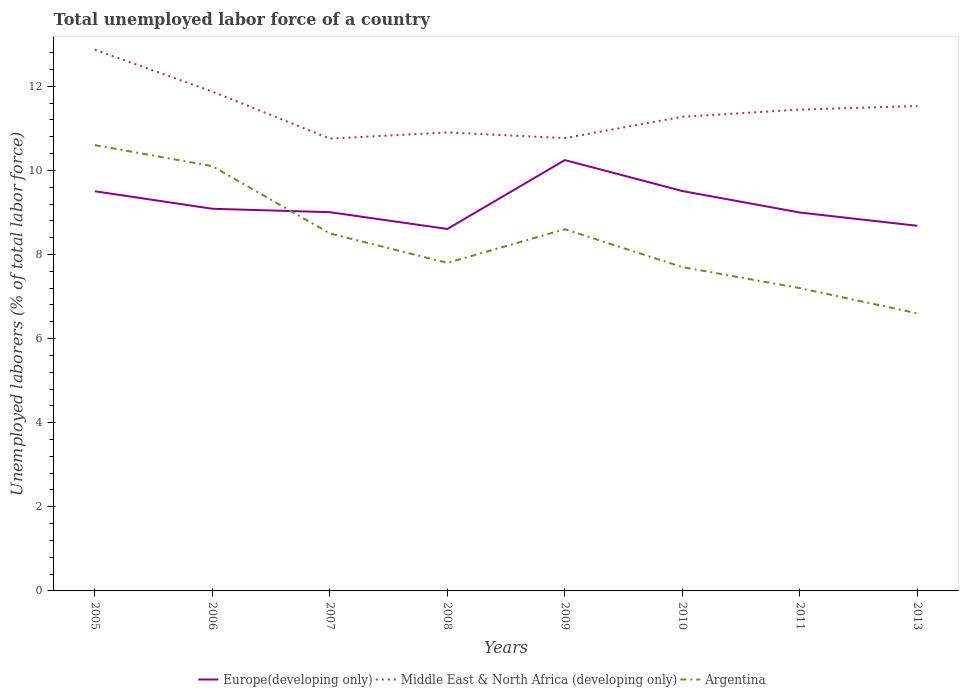How many different coloured lines are there?
Provide a short and direct response. 3. Is the number of lines equal to the number of legend labels?
Your answer should be very brief. Yes. Across all years, what is the maximum total unemployed labor force in Middle East & North Africa (developing only)?
Make the answer very short. 10.75. What is the total total unemployed labor force in Argentina in the graph?
Make the answer very short. 1.1. What is the difference between the highest and the second highest total unemployed labor force in Middle East & North Africa (developing only)?
Keep it short and to the point. 2.11. How many years are there in the graph?
Ensure brevity in your answer.  8. What is the difference between two consecutive major ticks on the Y-axis?
Make the answer very short. 2. Does the graph contain any zero values?
Offer a terse response. No. Does the graph contain grids?
Give a very brief answer. No. How many legend labels are there?
Give a very brief answer. 3. What is the title of the graph?
Your answer should be very brief. Total unemployed labor force of a country. What is the label or title of the Y-axis?
Offer a very short reply. Unemployed laborers (% of total labor force). What is the Unemployed laborers (% of total labor force) in Europe(developing only) in 2005?
Your answer should be very brief. 9.5. What is the Unemployed laborers (% of total labor force) of Middle East & North Africa (developing only) in 2005?
Keep it short and to the point. 12.87. What is the Unemployed laborers (% of total labor force) in Argentina in 2005?
Your answer should be compact. 10.6. What is the Unemployed laborers (% of total labor force) of Europe(developing only) in 2006?
Make the answer very short. 9.09. What is the Unemployed laborers (% of total labor force) of Middle East & North Africa (developing only) in 2006?
Ensure brevity in your answer.  11.87. What is the Unemployed laborers (% of total labor force) of Argentina in 2006?
Keep it short and to the point. 10.1. What is the Unemployed laborers (% of total labor force) in Europe(developing only) in 2007?
Provide a succinct answer. 9.01. What is the Unemployed laborers (% of total labor force) of Middle East & North Africa (developing only) in 2007?
Make the answer very short. 10.75. What is the Unemployed laborers (% of total labor force) in Argentina in 2007?
Offer a terse response. 8.5. What is the Unemployed laborers (% of total labor force) of Europe(developing only) in 2008?
Provide a succinct answer. 8.61. What is the Unemployed laborers (% of total labor force) of Middle East & North Africa (developing only) in 2008?
Your response must be concise. 10.9. What is the Unemployed laborers (% of total labor force) of Argentina in 2008?
Ensure brevity in your answer.  7.8. What is the Unemployed laborers (% of total labor force) in Europe(developing only) in 2009?
Your answer should be very brief. 10.24. What is the Unemployed laborers (% of total labor force) in Middle East & North Africa (developing only) in 2009?
Provide a succinct answer. 10.77. What is the Unemployed laborers (% of total labor force) in Argentina in 2009?
Ensure brevity in your answer.  8.6. What is the Unemployed laborers (% of total labor force) of Europe(developing only) in 2010?
Offer a terse response. 9.51. What is the Unemployed laborers (% of total labor force) of Middle East & North Africa (developing only) in 2010?
Offer a terse response. 11.28. What is the Unemployed laborers (% of total labor force) of Argentina in 2010?
Offer a terse response. 7.7. What is the Unemployed laborers (% of total labor force) of Europe(developing only) in 2011?
Ensure brevity in your answer.  9. What is the Unemployed laborers (% of total labor force) of Middle East & North Africa (developing only) in 2011?
Give a very brief answer. 11.44. What is the Unemployed laborers (% of total labor force) of Argentina in 2011?
Provide a short and direct response. 7.2. What is the Unemployed laborers (% of total labor force) in Europe(developing only) in 2013?
Make the answer very short. 8.68. What is the Unemployed laborers (% of total labor force) of Middle East & North Africa (developing only) in 2013?
Make the answer very short. 11.53. What is the Unemployed laborers (% of total labor force) in Argentina in 2013?
Provide a short and direct response. 6.6. Across all years, what is the maximum Unemployed laborers (% of total labor force) of Europe(developing only)?
Keep it short and to the point. 10.24. Across all years, what is the maximum Unemployed laborers (% of total labor force) of Middle East & North Africa (developing only)?
Your response must be concise. 12.87. Across all years, what is the maximum Unemployed laborers (% of total labor force) in Argentina?
Ensure brevity in your answer.  10.6. Across all years, what is the minimum Unemployed laborers (% of total labor force) of Europe(developing only)?
Make the answer very short. 8.61. Across all years, what is the minimum Unemployed laborers (% of total labor force) in Middle East & North Africa (developing only)?
Ensure brevity in your answer.  10.75. Across all years, what is the minimum Unemployed laborers (% of total labor force) in Argentina?
Make the answer very short. 6.6. What is the total Unemployed laborers (% of total labor force) in Europe(developing only) in the graph?
Make the answer very short. 73.63. What is the total Unemployed laborers (% of total labor force) of Middle East & North Africa (developing only) in the graph?
Provide a short and direct response. 91.41. What is the total Unemployed laborers (% of total labor force) of Argentina in the graph?
Ensure brevity in your answer.  67.1. What is the difference between the Unemployed laborers (% of total labor force) of Europe(developing only) in 2005 and that in 2006?
Offer a terse response. 0.42. What is the difference between the Unemployed laborers (% of total labor force) in Argentina in 2005 and that in 2006?
Make the answer very short. 0.5. What is the difference between the Unemployed laborers (% of total labor force) in Europe(developing only) in 2005 and that in 2007?
Provide a short and direct response. 0.5. What is the difference between the Unemployed laborers (% of total labor force) in Middle East & North Africa (developing only) in 2005 and that in 2007?
Ensure brevity in your answer.  2.11. What is the difference between the Unemployed laborers (% of total labor force) of Europe(developing only) in 2005 and that in 2008?
Your response must be concise. 0.9. What is the difference between the Unemployed laborers (% of total labor force) in Middle East & North Africa (developing only) in 2005 and that in 2008?
Make the answer very short. 1.97. What is the difference between the Unemployed laborers (% of total labor force) of Europe(developing only) in 2005 and that in 2009?
Your answer should be compact. -0.74. What is the difference between the Unemployed laborers (% of total labor force) of Middle East & North Africa (developing only) in 2005 and that in 2009?
Your answer should be compact. 2.1. What is the difference between the Unemployed laborers (% of total labor force) of Argentina in 2005 and that in 2009?
Ensure brevity in your answer.  2. What is the difference between the Unemployed laborers (% of total labor force) of Europe(developing only) in 2005 and that in 2010?
Offer a terse response. -0.01. What is the difference between the Unemployed laborers (% of total labor force) in Middle East & North Africa (developing only) in 2005 and that in 2010?
Offer a terse response. 1.59. What is the difference between the Unemployed laborers (% of total labor force) in Europe(developing only) in 2005 and that in 2011?
Your response must be concise. 0.51. What is the difference between the Unemployed laborers (% of total labor force) in Middle East & North Africa (developing only) in 2005 and that in 2011?
Your response must be concise. 1.42. What is the difference between the Unemployed laborers (% of total labor force) of Europe(developing only) in 2005 and that in 2013?
Offer a terse response. 0.82. What is the difference between the Unemployed laborers (% of total labor force) of Middle East & North Africa (developing only) in 2005 and that in 2013?
Keep it short and to the point. 1.34. What is the difference between the Unemployed laborers (% of total labor force) of Europe(developing only) in 2006 and that in 2007?
Provide a short and direct response. 0.08. What is the difference between the Unemployed laborers (% of total labor force) in Middle East & North Africa (developing only) in 2006 and that in 2007?
Provide a short and direct response. 1.12. What is the difference between the Unemployed laborers (% of total labor force) in Argentina in 2006 and that in 2007?
Offer a very short reply. 1.6. What is the difference between the Unemployed laborers (% of total labor force) in Europe(developing only) in 2006 and that in 2008?
Ensure brevity in your answer.  0.48. What is the difference between the Unemployed laborers (% of total labor force) in Middle East & North Africa (developing only) in 2006 and that in 2008?
Ensure brevity in your answer.  0.97. What is the difference between the Unemployed laborers (% of total labor force) of Argentina in 2006 and that in 2008?
Your response must be concise. 2.3. What is the difference between the Unemployed laborers (% of total labor force) in Europe(developing only) in 2006 and that in 2009?
Your answer should be compact. -1.16. What is the difference between the Unemployed laborers (% of total labor force) of Middle East & North Africa (developing only) in 2006 and that in 2009?
Provide a short and direct response. 1.11. What is the difference between the Unemployed laborers (% of total labor force) of Argentina in 2006 and that in 2009?
Your answer should be compact. 1.5. What is the difference between the Unemployed laborers (% of total labor force) of Europe(developing only) in 2006 and that in 2010?
Provide a succinct answer. -0.42. What is the difference between the Unemployed laborers (% of total labor force) of Middle East & North Africa (developing only) in 2006 and that in 2010?
Your answer should be compact. 0.6. What is the difference between the Unemployed laborers (% of total labor force) in Europe(developing only) in 2006 and that in 2011?
Your answer should be very brief. 0.09. What is the difference between the Unemployed laborers (% of total labor force) of Middle East & North Africa (developing only) in 2006 and that in 2011?
Provide a short and direct response. 0.43. What is the difference between the Unemployed laborers (% of total labor force) of Argentina in 2006 and that in 2011?
Offer a very short reply. 2.9. What is the difference between the Unemployed laborers (% of total labor force) in Europe(developing only) in 2006 and that in 2013?
Give a very brief answer. 0.4. What is the difference between the Unemployed laborers (% of total labor force) of Middle East & North Africa (developing only) in 2006 and that in 2013?
Offer a very short reply. 0.34. What is the difference between the Unemployed laborers (% of total labor force) in Europe(developing only) in 2007 and that in 2008?
Give a very brief answer. 0.4. What is the difference between the Unemployed laborers (% of total labor force) in Middle East & North Africa (developing only) in 2007 and that in 2008?
Your response must be concise. -0.15. What is the difference between the Unemployed laborers (% of total labor force) in Argentina in 2007 and that in 2008?
Your response must be concise. 0.7. What is the difference between the Unemployed laborers (% of total labor force) of Europe(developing only) in 2007 and that in 2009?
Ensure brevity in your answer.  -1.24. What is the difference between the Unemployed laborers (% of total labor force) of Middle East & North Africa (developing only) in 2007 and that in 2009?
Give a very brief answer. -0.01. What is the difference between the Unemployed laborers (% of total labor force) in Argentina in 2007 and that in 2009?
Give a very brief answer. -0.1. What is the difference between the Unemployed laborers (% of total labor force) in Europe(developing only) in 2007 and that in 2010?
Ensure brevity in your answer.  -0.5. What is the difference between the Unemployed laborers (% of total labor force) of Middle East & North Africa (developing only) in 2007 and that in 2010?
Provide a succinct answer. -0.52. What is the difference between the Unemployed laborers (% of total labor force) of Argentina in 2007 and that in 2010?
Your answer should be compact. 0.8. What is the difference between the Unemployed laborers (% of total labor force) of Europe(developing only) in 2007 and that in 2011?
Ensure brevity in your answer.  0.01. What is the difference between the Unemployed laborers (% of total labor force) of Middle East & North Africa (developing only) in 2007 and that in 2011?
Offer a terse response. -0.69. What is the difference between the Unemployed laborers (% of total labor force) of Europe(developing only) in 2007 and that in 2013?
Make the answer very short. 0.32. What is the difference between the Unemployed laborers (% of total labor force) in Middle East & North Africa (developing only) in 2007 and that in 2013?
Offer a terse response. -0.77. What is the difference between the Unemployed laborers (% of total labor force) of Argentina in 2007 and that in 2013?
Your answer should be compact. 1.9. What is the difference between the Unemployed laborers (% of total labor force) of Europe(developing only) in 2008 and that in 2009?
Offer a very short reply. -1.64. What is the difference between the Unemployed laborers (% of total labor force) of Middle East & North Africa (developing only) in 2008 and that in 2009?
Offer a very short reply. 0.14. What is the difference between the Unemployed laborers (% of total labor force) in Europe(developing only) in 2008 and that in 2010?
Give a very brief answer. -0.9. What is the difference between the Unemployed laborers (% of total labor force) in Middle East & North Africa (developing only) in 2008 and that in 2010?
Offer a terse response. -0.37. What is the difference between the Unemployed laborers (% of total labor force) in Argentina in 2008 and that in 2010?
Offer a terse response. 0.1. What is the difference between the Unemployed laborers (% of total labor force) in Europe(developing only) in 2008 and that in 2011?
Your response must be concise. -0.39. What is the difference between the Unemployed laborers (% of total labor force) in Middle East & North Africa (developing only) in 2008 and that in 2011?
Provide a short and direct response. -0.54. What is the difference between the Unemployed laborers (% of total labor force) in Europe(developing only) in 2008 and that in 2013?
Your answer should be very brief. -0.08. What is the difference between the Unemployed laborers (% of total labor force) of Middle East & North Africa (developing only) in 2008 and that in 2013?
Provide a succinct answer. -0.63. What is the difference between the Unemployed laborers (% of total labor force) of Europe(developing only) in 2009 and that in 2010?
Your answer should be compact. 0.74. What is the difference between the Unemployed laborers (% of total labor force) in Middle East & North Africa (developing only) in 2009 and that in 2010?
Give a very brief answer. -0.51. What is the difference between the Unemployed laborers (% of total labor force) of Europe(developing only) in 2009 and that in 2011?
Ensure brevity in your answer.  1.25. What is the difference between the Unemployed laborers (% of total labor force) in Middle East & North Africa (developing only) in 2009 and that in 2011?
Offer a very short reply. -0.68. What is the difference between the Unemployed laborers (% of total labor force) of Europe(developing only) in 2009 and that in 2013?
Ensure brevity in your answer.  1.56. What is the difference between the Unemployed laborers (% of total labor force) of Middle East & North Africa (developing only) in 2009 and that in 2013?
Your answer should be very brief. -0.76. What is the difference between the Unemployed laborers (% of total labor force) of Europe(developing only) in 2010 and that in 2011?
Your answer should be compact. 0.51. What is the difference between the Unemployed laborers (% of total labor force) in Middle East & North Africa (developing only) in 2010 and that in 2011?
Give a very brief answer. -0.17. What is the difference between the Unemployed laborers (% of total labor force) of Argentina in 2010 and that in 2011?
Your answer should be very brief. 0.5. What is the difference between the Unemployed laborers (% of total labor force) in Europe(developing only) in 2010 and that in 2013?
Offer a terse response. 0.83. What is the difference between the Unemployed laborers (% of total labor force) in Middle East & North Africa (developing only) in 2010 and that in 2013?
Ensure brevity in your answer.  -0.25. What is the difference between the Unemployed laborers (% of total labor force) of Argentina in 2010 and that in 2013?
Provide a short and direct response. 1.1. What is the difference between the Unemployed laborers (% of total labor force) in Europe(developing only) in 2011 and that in 2013?
Offer a terse response. 0.32. What is the difference between the Unemployed laborers (% of total labor force) in Middle East & North Africa (developing only) in 2011 and that in 2013?
Make the answer very short. -0.09. What is the difference between the Unemployed laborers (% of total labor force) of Europe(developing only) in 2005 and the Unemployed laborers (% of total labor force) of Middle East & North Africa (developing only) in 2006?
Your response must be concise. -2.37. What is the difference between the Unemployed laborers (% of total labor force) in Europe(developing only) in 2005 and the Unemployed laborers (% of total labor force) in Argentina in 2006?
Offer a terse response. -0.6. What is the difference between the Unemployed laborers (% of total labor force) in Middle East & North Africa (developing only) in 2005 and the Unemployed laborers (% of total labor force) in Argentina in 2006?
Keep it short and to the point. 2.77. What is the difference between the Unemployed laborers (% of total labor force) of Europe(developing only) in 2005 and the Unemployed laborers (% of total labor force) of Middle East & North Africa (developing only) in 2007?
Offer a very short reply. -1.25. What is the difference between the Unemployed laborers (% of total labor force) of Europe(developing only) in 2005 and the Unemployed laborers (% of total labor force) of Argentina in 2007?
Offer a terse response. 1. What is the difference between the Unemployed laborers (% of total labor force) in Middle East & North Africa (developing only) in 2005 and the Unemployed laborers (% of total labor force) in Argentina in 2007?
Your answer should be compact. 4.37. What is the difference between the Unemployed laborers (% of total labor force) in Europe(developing only) in 2005 and the Unemployed laborers (% of total labor force) in Middle East & North Africa (developing only) in 2008?
Your response must be concise. -1.4. What is the difference between the Unemployed laborers (% of total labor force) in Europe(developing only) in 2005 and the Unemployed laborers (% of total labor force) in Argentina in 2008?
Keep it short and to the point. 1.7. What is the difference between the Unemployed laborers (% of total labor force) in Middle East & North Africa (developing only) in 2005 and the Unemployed laborers (% of total labor force) in Argentina in 2008?
Offer a very short reply. 5.07. What is the difference between the Unemployed laborers (% of total labor force) in Europe(developing only) in 2005 and the Unemployed laborers (% of total labor force) in Middle East & North Africa (developing only) in 2009?
Offer a terse response. -1.26. What is the difference between the Unemployed laborers (% of total labor force) in Europe(developing only) in 2005 and the Unemployed laborers (% of total labor force) in Argentina in 2009?
Provide a succinct answer. 0.9. What is the difference between the Unemployed laborers (% of total labor force) in Middle East & North Africa (developing only) in 2005 and the Unemployed laborers (% of total labor force) in Argentina in 2009?
Ensure brevity in your answer.  4.27. What is the difference between the Unemployed laborers (% of total labor force) of Europe(developing only) in 2005 and the Unemployed laborers (% of total labor force) of Middle East & North Africa (developing only) in 2010?
Provide a short and direct response. -1.77. What is the difference between the Unemployed laborers (% of total labor force) of Europe(developing only) in 2005 and the Unemployed laborers (% of total labor force) of Argentina in 2010?
Keep it short and to the point. 1.8. What is the difference between the Unemployed laborers (% of total labor force) in Middle East & North Africa (developing only) in 2005 and the Unemployed laborers (% of total labor force) in Argentina in 2010?
Ensure brevity in your answer.  5.17. What is the difference between the Unemployed laborers (% of total labor force) of Europe(developing only) in 2005 and the Unemployed laborers (% of total labor force) of Middle East & North Africa (developing only) in 2011?
Keep it short and to the point. -1.94. What is the difference between the Unemployed laborers (% of total labor force) of Europe(developing only) in 2005 and the Unemployed laborers (% of total labor force) of Argentina in 2011?
Ensure brevity in your answer.  2.3. What is the difference between the Unemployed laborers (% of total labor force) of Middle East & North Africa (developing only) in 2005 and the Unemployed laborers (% of total labor force) of Argentina in 2011?
Your response must be concise. 5.67. What is the difference between the Unemployed laborers (% of total labor force) in Europe(developing only) in 2005 and the Unemployed laborers (% of total labor force) in Middle East & North Africa (developing only) in 2013?
Ensure brevity in your answer.  -2.03. What is the difference between the Unemployed laborers (% of total labor force) in Europe(developing only) in 2005 and the Unemployed laborers (% of total labor force) in Argentina in 2013?
Your response must be concise. 2.9. What is the difference between the Unemployed laborers (% of total labor force) of Middle East & North Africa (developing only) in 2005 and the Unemployed laborers (% of total labor force) of Argentina in 2013?
Your answer should be compact. 6.27. What is the difference between the Unemployed laborers (% of total labor force) in Europe(developing only) in 2006 and the Unemployed laborers (% of total labor force) in Middle East & North Africa (developing only) in 2007?
Your answer should be very brief. -1.67. What is the difference between the Unemployed laborers (% of total labor force) of Europe(developing only) in 2006 and the Unemployed laborers (% of total labor force) of Argentina in 2007?
Provide a short and direct response. 0.59. What is the difference between the Unemployed laborers (% of total labor force) of Middle East & North Africa (developing only) in 2006 and the Unemployed laborers (% of total labor force) of Argentina in 2007?
Provide a succinct answer. 3.37. What is the difference between the Unemployed laborers (% of total labor force) in Europe(developing only) in 2006 and the Unemployed laborers (% of total labor force) in Middle East & North Africa (developing only) in 2008?
Give a very brief answer. -1.82. What is the difference between the Unemployed laborers (% of total labor force) of Europe(developing only) in 2006 and the Unemployed laborers (% of total labor force) of Argentina in 2008?
Provide a short and direct response. 1.29. What is the difference between the Unemployed laborers (% of total labor force) in Middle East & North Africa (developing only) in 2006 and the Unemployed laborers (% of total labor force) in Argentina in 2008?
Your response must be concise. 4.07. What is the difference between the Unemployed laborers (% of total labor force) of Europe(developing only) in 2006 and the Unemployed laborers (% of total labor force) of Middle East & North Africa (developing only) in 2009?
Ensure brevity in your answer.  -1.68. What is the difference between the Unemployed laborers (% of total labor force) in Europe(developing only) in 2006 and the Unemployed laborers (% of total labor force) in Argentina in 2009?
Provide a succinct answer. 0.49. What is the difference between the Unemployed laborers (% of total labor force) of Middle East & North Africa (developing only) in 2006 and the Unemployed laborers (% of total labor force) of Argentina in 2009?
Your response must be concise. 3.27. What is the difference between the Unemployed laborers (% of total labor force) in Europe(developing only) in 2006 and the Unemployed laborers (% of total labor force) in Middle East & North Africa (developing only) in 2010?
Offer a terse response. -2.19. What is the difference between the Unemployed laborers (% of total labor force) of Europe(developing only) in 2006 and the Unemployed laborers (% of total labor force) of Argentina in 2010?
Your answer should be compact. 1.39. What is the difference between the Unemployed laborers (% of total labor force) of Middle East & North Africa (developing only) in 2006 and the Unemployed laborers (% of total labor force) of Argentina in 2010?
Offer a very short reply. 4.17. What is the difference between the Unemployed laborers (% of total labor force) in Europe(developing only) in 2006 and the Unemployed laborers (% of total labor force) in Middle East & North Africa (developing only) in 2011?
Make the answer very short. -2.36. What is the difference between the Unemployed laborers (% of total labor force) of Europe(developing only) in 2006 and the Unemployed laborers (% of total labor force) of Argentina in 2011?
Offer a very short reply. 1.89. What is the difference between the Unemployed laborers (% of total labor force) of Middle East & North Africa (developing only) in 2006 and the Unemployed laborers (% of total labor force) of Argentina in 2011?
Your answer should be very brief. 4.67. What is the difference between the Unemployed laborers (% of total labor force) of Europe(developing only) in 2006 and the Unemployed laborers (% of total labor force) of Middle East & North Africa (developing only) in 2013?
Make the answer very short. -2.44. What is the difference between the Unemployed laborers (% of total labor force) in Europe(developing only) in 2006 and the Unemployed laborers (% of total labor force) in Argentina in 2013?
Your answer should be very brief. 2.49. What is the difference between the Unemployed laborers (% of total labor force) in Middle East & North Africa (developing only) in 2006 and the Unemployed laborers (% of total labor force) in Argentina in 2013?
Provide a succinct answer. 5.27. What is the difference between the Unemployed laborers (% of total labor force) in Europe(developing only) in 2007 and the Unemployed laborers (% of total labor force) in Middle East & North Africa (developing only) in 2008?
Give a very brief answer. -1.9. What is the difference between the Unemployed laborers (% of total labor force) of Europe(developing only) in 2007 and the Unemployed laborers (% of total labor force) of Argentina in 2008?
Offer a terse response. 1.21. What is the difference between the Unemployed laborers (% of total labor force) in Middle East & North Africa (developing only) in 2007 and the Unemployed laborers (% of total labor force) in Argentina in 2008?
Offer a terse response. 2.95. What is the difference between the Unemployed laborers (% of total labor force) of Europe(developing only) in 2007 and the Unemployed laborers (% of total labor force) of Middle East & North Africa (developing only) in 2009?
Your response must be concise. -1.76. What is the difference between the Unemployed laborers (% of total labor force) of Europe(developing only) in 2007 and the Unemployed laborers (% of total labor force) of Argentina in 2009?
Ensure brevity in your answer.  0.41. What is the difference between the Unemployed laborers (% of total labor force) in Middle East & North Africa (developing only) in 2007 and the Unemployed laborers (% of total labor force) in Argentina in 2009?
Provide a succinct answer. 2.15. What is the difference between the Unemployed laborers (% of total labor force) in Europe(developing only) in 2007 and the Unemployed laborers (% of total labor force) in Middle East & North Africa (developing only) in 2010?
Offer a very short reply. -2.27. What is the difference between the Unemployed laborers (% of total labor force) of Europe(developing only) in 2007 and the Unemployed laborers (% of total labor force) of Argentina in 2010?
Offer a terse response. 1.31. What is the difference between the Unemployed laborers (% of total labor force) in Middle East & North Africa (developing only) in 2007 and the Unemployed laborers (% of total labor force) in Argentina in 2010?
Give a very brief answer. 3.05. What is the difference between the Unemployed laborers (% of total labor force) in Europe(developing only) in 2007 and the Unemployed laborers (% of total labor force) in Middle East & North Africa (developing only) in 2011?
Your answer should be very brief. -2.44. What is the difference between the Unemployed laborers (% of total labor force) of Europe(developing only) in 2007 and the Unemployed laborers (% of total labor force) of Argentina in 2011?
Provide a succinct answer. 1.81. What is the difference between the Unemployed laborers (% of total labor force) in Middle East & North Africa (developing only) in 2007 and the Unemployed laborers (% of total labor force) in Argentina in 2011?
Give a very brief answer. 3.55. What is the difference between the Unemployed laborers (% of total labor force) of Europe(developing only) in 2007 and the Unemployed laborers (% of total labor force) of Middle East & North Africa (developing only) in 2013?
Provide a short and direct response. -2.52. What is the difference between the Unemployed laborers (% of total labor force) of Europe(developing only) in 2007 and the Unemployed laborers (% of total labor force) of Argentina in 2013?
Keep it short and to the point. 2.41. What is the difference between the Unemployed laborers (% of total labor force) in Middle East & North Africa (developing only) in 2007 and the Unemployed laborers (% of total labor force) in Argentina in 2013?
Your answer should be compact. 4.15. What is the difference between the Unemployed laborers (% of total labor force) of Europe(developing only) in 2008 and the Unemployed laborers (% of total labor force) of Middle East & North Africa (developing only) in 2009?
Ensure brevity in your answer.  -2.16. What is the difference between the Unemployed laborers (% of total labor force) of Europe(developing only) in 2008 and the Unemployed laborers (% of total labor force) of Argentina in 2009?
Your answer should be compact. 0.01. What is the difference between the Unemployed laborers (% of total labor force) in Middle East & North Africa (developing only) in 2008 and the Unemployed laborers (% of total labor force) in Argentina in 2009?
Offer a terse response. 2.3. What is the difference between the Unemployed laborers (% of total labor force) in Europe(developing only) in 2008 and the Unemployed laborers (% of total labor force) in Middle East & North Africa (developing only) in 2010?
Your answer should be compact. -2.67. What is the difference between the Unemployed laborers (% of total labor force) of Europe(developing only) in 2008 and the Unemployed laborers (% of total labor force) of Argentina in 2010?
Make the answer very short. 0.91. What is the difference between the Unemployed laborers (% of total labor force) of Middle East & North Africa (developing only) in 2008 and the Unemployed laborers (% of total labor force) of Argentina in 2010?
Provide a succinct answer. 3.2. What is the difference between the Unemployed laborers (% of total labor force) of Europe(developing only) in 2008 and the Unemployed laborers (% of total labor force) of Middle East & North Africa (developing only) in 2011?
Keep it short and to the point. -2.84. What is the difference between the Unemployed laborers (% of total labor force) in Europe(developing only) in 2008 and the Unemployed laborers (% of total labor force) in Argentina in 2011?
Keep it short and to the point. 1.41. What is the difference between the Unemployed laborers (% of total labor force) in Middle East & North Africa (developing only) in 2008 and the Unemployed laborers (% of total labor force) in Argentina in 2011?
Your answer should be compact. 3.7. What is the difference between the Unemployed laborers (% of total labor force) of Europe(developing only) in 2008 and the Unemployed laborers (% of total labor force) of Middle East & North Africa (developing only) in 2013?
Your response must be concise. -2.92. What is the difference between the Unemployed laborers (% of total labor force) in Europe(developing only) in 2008 and the Unemployed laborers (% of total labor force) in Argentina in 2013?
Give a very brief answer. 2.01. What is the difference between the Unemployed laborers (% of total labor force) of Middle East & North Africa (developing only) in 2008 and the Unemployed laborers (% of total labor force) of Argentina in 2013?
Make the answer very short. 4.3. What is the difference between the Unemployed laborers (% of total labor force) in Europe(developing only) in 2009 and the Unemployed laborers (% of total labor force) in Middle East & North Africa (developing only) in 2010?
Provide a succinct answer. -1.03. What is the difference between the Unemployed laborers (% of total labor force) of Europe(developing only) in 2009 and the Unemployed laborers (% of total labor force) of Argentina in 2010?
Your answer should be very brief. 2.54. What is the difference between the Unemployed laborers (% of total labor force) in Middle East & North Africa (developing only) in 2009 and the Unemployed laborers (% of total labor force) in Argentina in 2010?
Keep it short and to the point. 3.07. What is the difference between the Unemployed laborers (% of total labor force) in Europe(developing only) in 2009 and the Unemployed laborers (% of total labor force) in Middle East & North Africa (developing only) in 2011?
Ensure brevity in your answer.  -1.2. What is the difference between the Unemployed laborers (% of total labor force) of Europe(developing only) in 2009 and the Unemployed laborers (% of total labor force) of Argentina in 2011?
Keep it short and to the point. 3.04. What is the difference between the Unemployed laborers (% of total labor force) of Middle East & North Africa (developing only) in 2009 and the Unemployed laborers (% of total labor force) of Argentina in 2011?
Offer a terse response. 3.57. What is the difference between the Unemployed laborers (% of total labor force) of Europe(developing only) in 2009 and the Unemployed laborers (% of total labor force) of Middle East & North Africa (developing only) in 2013?
Offer a terse response. -1.29. What is the difference between the Unemployed laborers (% of total labor force) of Europe(developing only) in 2009 and the Unemployed laborers (% of total labor force) of Argentina in 2013?
Ensure brevity in your answer.  3.64. What is the difference between the Unemployed laborers (% of total labor force) of Middle East & North Africa (developing only) in 2009 and the Unemployed laborers (% of total labor force) of Argentina in 2013?
Provide a succinct answer. 4.17. What is the difference between the Unemployed laborers (% of total labor force) of Europe(developing only) in 2010 and the Unemployed laborers (% of total labor force) of Middle East & North Africa (developing only) in 2011?
Make the answer very short. -1.94. What is the difference between the Unemployed laborers (% of total labor force) in Europe(developing only) in 2010 and the Unemployed laborers (% of total labor force) in Argentina in 2011?
Provide a short and direct response. 2.31. What is the difference between the Unemployed laborers (% of total labor force) of Middle East & North Africa (developing only) in 2010 and the Unemployed laborers (% of total labor force) of Argentina in 2011?
Provide a short and direct response. 4.08. What is the difference between the Unemployed laborers (% of total labor force) of Europe(developing only) in 2010 and the Unemployed laborers (% of total labor force) of Middle East & North Africa (developing only) in 2013?
Your answer should be compact. -2.02. What is the difference between the Unemployed laborers (% of total labor force) in Europe(developing only) in 2010 and the Unemployed laborers (% of total labor force) in Argentina in 2013?
Your response must be concise. 2.91. What is the difference between the Unemployed laborers (% of total labor force) in Middle East & North Africa (developing only) in 2010 and the Unemployed laborers (% of total labor force) in Argentina in 2013?
Give a very brief answer. 4.68. What is the difference between the Unemployed laborers (% of total labor force) in Europe(developing only) in 2011 and the Unemployed laborers (% of total labor force) in Middle East & North Africa (developing only) in 2013?
Keep it short and to the point. -2.53. What is the difference between the Unemployed laborers (% of total labor force) in Europe(developing only) in 2011 and the Unemployed laborers (% of total labor force) in Argentina in 2013?
Your response must be concise. 2.4. What is the difference between the Unemployed laborers (% of total labor force) in Middle East & North Africa (developing only) in 2011 and the Unemployed laborers (% of total labor force) in Argentina in 2013?
Offer a terse response. 4.84. What is the average Unemployed laborers (% of total labor force) in Europe(developing only) per year?
Make the answer very short. 9.2. What is the average Unemployed laborers (% of total labor force) of Middle East & North Africa (developing only) per year?
Make the answer very short. 11.43. What is the average Unemployed laborers (% of total labor force) of Argentina per year?
Make the answer very short. 8.39. In the year 2005, what is the difference between the Unemployed laborers (% of total labor force) of Europe(developing only) and Unemployed laborers (% of total labor force) of Middle East & North Africa (developing only)?
Give a very brief answer. -3.36. In the year 2005, what is the difference between the Unemployed laborers (% of total labor force) of Europe(developing only) and Unemployed laborers (% of total labor force) of Argentina?
Provide a short and direct response. -1.1. In the year 2005, what is the difference between the Unemployed laborers (% of total labor force) of Middle East & North Africa (developing only) and Unemployed laborers (% of total labor force) of Argentina?
Keep it short and to the point. 2.27. In the year 2006, what is the difference between the Unemployed laborers (% of total labor force) of Europe(developing only) and Unemployed laborers (% of total labor force) of Middle East & North Africa (developing only)?
Offer a very short reply. -2.79. In the year 2006, what is the difference between the Unemployed laborers (% of total labor force) in Europe(developing only) and Unemployed laborers (% of total labor force) in Argentina?
Your answer should be very brief. -1.01. In the year 2006, what is the difference between the Unemployed laborers (% of total labor force) of Middle East & North Africa (developing only) and Unemployed laborers (% of total labor force) of Argentina?
Ensure brevity in your answer.  1.77. In the year 2007, what is the difference between the Unemployed laborers (% of total labor force) in Europe(developing only) and Unemployed laborers (% of total labor force) in Middle East & North Africa (developing only)?
Your response must be concise. -1.75. In the year 2007, what is the difference between the Unemployed laborers (% of total labor force) in Europe(developing only) and Unemployed laborers (% of total labor force) in Argentina?
Make the answer very short. 0.51. In the year 2007, what is the difference between the Unemployed laborers (% of total labor force) in Middle East & North Africa (developing only) and Unemployed laborers (% of total labor force) in Argentina?
Give a very brief answer. 2.25. In the year 2008, what is the difference between the Unemployed laborers (% of total labor force) of Europe(developing only) and Unemployed laborers (% of total labor force) of Middle East & North Africa (developing only)?
Give a very brief answer. -2.3. In the year 2008, what is the difference between the Unemployed laborers (% of total labor force) in Europe(developing only) and Unemployed laborers (% of total labor force) in Argentina?
Provide a succinct answer. 0.81. In the year 2008, what is the difference between the Unemployed laborers (% of total labor force) in Middle East & North Africa (developing only) and Unemployed laborers (% of total labor force) in Argentina?
Offer a terse response. 3.1. In the year 2009, what is the difference between the Unemployed laborers (% of total labor force) in Europe(developing only) and Unemployed laborers (% of total labor force) in Middle East & North Africa (developing only)?
Provide a succinct answer. -0.52. In the year 2009, what is the difference between the Unemployed laborers (% of total labor force) of Europe(developing only) and Unemployed laborers (% of total labor force) of Argentina?
Provide a succinct answer. 1.64. In the year 2009, what is the difference between the Unemployed laborers (% of total labor force) in Middle East & North Africa (developing only) and Unemployed laborers (% of total labor force) in Argentina?
Your response must be concise. 2.17. In the year 2010, what is the difference between the Unemployed laborers (% of total labor force) of Europe(developing only) and Unemployed laborers (% of total labor force) of Middle East & North Africa (developing only)?
Keep it short and to the point. -1.77. In the year 2010, what is the difference between the Unemployed laborers (% of total labor force) in Europe(developing only) and Unemployed laborers (% of total labor force) in Argentina?
Offer a very short reply. 1.81. In the year 2010, what is the difference between the Unemployed laborers (% of total labor force) of Middle East & North Africa (developing only) and Unemployed laborers (% of total labor force) of Argentina?
Keep it short and to the point. 3.58. In the year 2011, what is the difference between the Unemployed laborers (% of total labor force) of Europe(developing only) and Unemployed laborers (% of total labor force) of Middle East & North Africa (developing only)?
Your answer should be compact. -2.45. In the year 2011, what is the difference between the Unemployed laborers (% of total labor force) of Europe(developing only) and Unemployed laborers (% of total labor force) of Argentina?
Offer a very short reply. 1.8. In the year 2011, what is the difference between the Unemployed laborers (% of total labor force) of Middle East & North Africa (developing only) and Unemployed laborers (% of total labor force) of Argentina?
Keep it short and to the point. 4.24. In the year 2013, what is the difference between the Unemployed laborers (% of total labor force) of Europe(developing only) and Unemployed laborers (% of total labor force) of Middle East & North Africa (developing only)?
Offer a terse response. -2.85. In the year 2013, what is the difference between the Unemployed laborers (% of total labor force) of Europe(developing only) and Unemployed laborers (% of total labor force) of Argentina?
Your response must be concise. 2.08. In the year 2013, what is the difference between the Unemployed laborers (% of total labor force) of Middle East & North Africa (developing only) and Unemployed laborers (% of total labor force) of Argentina?
Offer a terse response. 4.93. What is the ratio of the Unemployed laborers (% of total labor force) in Europe(developing only) in 2005 to that in 2006?
Your answer should be compact. 1.05. What is the ratio of the Unemployed laborers (% of total labor force) of Middle East & North Africa (developing only) in 2005 to that in 2006?
Offer a very short reply. 1.08. What is the ratio of the Unemployed laborers (% of total labor force) of Argentina in 2005 to that in 2006?
Your answer should be very brief. 1.05. What is the ratio of the Unemployed laborers (% of total labor force) of Europe(developing only) in 2005 to that in 2007?
Your answer should be very brief. 1.06. What is the ratio of the Unemployed laborers (% of total labor force) in Middle East & North Africa (developing only) in 2005 to that in 2007?
Offer a very short reply. 1.2. What is the ratio of the Unemployed laborers (% of total labor force) in Argentina in 2005 to that in 2007?
Your answer should be compact. 1.25. What is the ratio of the Unemployed laborers (% of total labor force) in Europe(developing only) in 2005 to that in 2008?
Your response must be concise. 1.1. What is the ratio of the Unemployed laborers (% of total labor force) in Middle East & North Africa (developing only) in 2005 to that in 2008?
Keep it short and to the point. 1.18. What is the ratio of the Unemployed laborers (% of total labor force) in Argentina in 2005 to that in 2008?
Keep it short and to the point. 1.36. What is the ratio of the Unemployed laborers (% of total labor force) of Europe(developing only) in 2005 to that in 2009?
Provide a succinct answer. 0.93. What is the ratio of the Unemployed laborers (% of total labor force) in Middle East & North Africa (developing only) in 2005 to that in 2009?
Provide a short and direct response. 1.2. What is the ratio of the Unemployed laborers (% of total labor force) of Argentina in 2005 to that in 2009?
Give a very brief answer. 1.23. What is the ratio of the Unemployed laborers (% of total labor force) in Europe(developing only) in 2005 to that in 2010?
Keep it short and to the point. 1. What is the ratio of the Unemployed laborers (% of total labor force) in Middle East & North Africa (developing only) in 2005 to that in 2010?
Provide a short and direct response. 1.14. What is the ratio of the Unemployed laborers (% of total labor force) of Argentina in 2005 to that in 2010?
Your answer should be compact. 1.38. What is the ratio of the Unemployed laborers (% of total labor force) in Europe(developing only) in 2005 to that in 2011?
Make the answer very short. 1.06. What is the ratio of the Unemployed laborers (% of total labor force) of Middle East & North Africa (developing only) in 2005 to that in 2011?
Offer a very short reply. 1.12. What is the ratio of the Unemployed laborers (% of total labor force) of Argentina in 2005 to that in 2011?
Keep it short and to the point. 1.47. What is the ratio of the Unemployed laborers (% of total labor force) of Europe(developing only) in 2005 to that in 2013?
Provide a short and direct response. 1.09. What is the ratio of the Unemployed laborers (% of total labor force) in Middle East & North Africa (developing only) in 2005 to that in 2013?
Your answer should be very brief. 1.12. What is the ratio of the Unemployed laborers (% of total labor force) in Argentina in 2005 to that in 2013?
Your response must be concise. 1.61. What is the ratio of the Unemployed laborers (% of total labor force) of Middle East & North Africa (developing only) in 2006 to that in 2007?
Ensure brevity in your answer.  1.1. What is the ratio of the Unemployed laborers (% of total labor force) in Argentina in 2006 to that in 2007?
Your response must be concise. 1.19. What is the ratio of the Unemployed laborers (% of total labor force) of Europe(developing only) in 2006 to that in 2008?
Your answer should be compact. 1.06. What is the ratio of the Unemployed laborers (% of total labor force) of Middle East & North Africa (developing only) in 2006 to that in 2008?
Offer a very short reply. 1.09. What is the ratio of the Unemployed laborers (% of total labor force) of Argentina in 2006 to that in 2008?
Keep it short and to the point. 1.29. What is the ratio of the Unemployed laborers (% of total labor force) of Europe(developing only) in 2006 to that in 2009?
Offer a terse response. 0.89. What is the ratio of the Unemployed laborers (% of total labor force) of Middle East & North Africa (developing only) in 2006 to that in 2009?
Provide a succinct answer. 1.1. What is the ratio of the Unemployed laborers (% of total labor force) of Argentina in 2006 to that in 2009?
Offer a terse response. 1.17. What is the ratio of the Unemployed laborers (% of total labor force) in Europe(developing only) in 2006 to that in 2010?
Provide a short and direct response. 0.96. What is the ratio of the Unemployed laborers (% of total labor force) of Middle East & North Africa (developing only) in 2006 to that in 2010?
Your answer should be very brief. 1.05. What is the ratio of the Unemployed laborers (% of total labor force) in Argentina in 2006 to that in 2010?
Your response must be concise. 1.31. What is the ratio of the Unemployed laborers (% of total labor force) in Europe(developing only) in 2006 to that in 2011?
Your answer should be very brief. 1.01. What is the ratio of the Unemployed laborers (% of total labor force) in Middle East & North Africa (developing only) in 2006 to that in 2011?
Your response must be concise. 1.04. What is the ratio of the Unemployed laborers (% of total labor force) of Argentina in 2006 to that in 2011?
Your response must be concise. 1.4. What is the ratio of the Unemployed laborers (% of total labor force) of Europe(developing only) in 2006 to that in 2013?
Keep it short and to the point. 1.05. What is the ratio of the Unemployed laborers (% of total labor force) in Middle East & North Africa (developing only) in 2006 to that in 2013?
Make the answer very short. 1.03. What is the ratio of the Unemployed laborers (% of total labor force) of Argentina in 2006 to that in 2013?
Provide a succinct answer. 1.53. What is the ratio of the Unemployed laborers (% of total labor force) of Europe(developing only) in 2007 to that in 2008?
Keep it short and to the point. 1.05. What is the ratio of the Unemployed laborers (% of total labor force) of Middle East & North Africa (developing only) in 2007 to that in 2008?
Your answer should be compact. 0.99. What is the ratio of the Unemployed laborers (% of total labor force) in Argentina in 2007 to that in 2008?
Offer a very short reply. 1.09. What is the ratio of the Unemployed laborers (% of total labor force) of Europe(developing only) in 2007 to that in 2009?
Your response must be concise. 0.88. What is the ratio of the Unemployed laborers (% of total labor force) of Middle East & North Africa (developing only) in 2007 to that in 2009?
Provide a succinct answer. 1. What is the ratio of the Unemployed laborers (% of total labor force) of Argentina in 2007 to that in 2009?
Make the answer very short. 0.99. What is the ratio of the Unemployed laborers (% of total labor force) of Europe(developing only) in 2007 to that in 2010?
Your answer should be compact. 0.95. What is the ratio of the Unemployed laborers (% of total labor force) of Middle East & North Africa (developing only) in 2007 to that in 2010?
Provide a succinct answer. 0.95. What is the ratio of the Unemployed laborers (% of total labor force) in Argentina in 2007 to that in 2010?
Offer a very short reply. 1.1. What is the ratio of the Unemployed laborers (% of total labor force) in Middle East & North Africa (developing only) in 2007 to that in 2011?
Keep it short and to the point. 0.94. What is the ratio of the Unemployed laborers (% of total labor force) in Argentina in 2007 to that in 2011?
Offer a terse response. 1.18. What is the ratio of the Unemployed laborers (% of total labor force) in Europe(developing only) in 2007 to that in 2013?
Provide a succinct answer. 1.04. What is the ratio of the Unemployed laborers (% of total labor force) in Middle East & North Africa (developing only) in 2007 to that in 2013?
Offer a very short reply. 0.93. What is the ratio of the Unemployed laborers (% of total labor force) in Argentina in 2007 to that in 2013?
Your answer should be compact. 1.29. What is the ratio of the Unemployed laborers (% of total labor force) of Europe(developing only) in 2008 to that in 2009?
Provide a short and direct response. 0.84. What is the ratio of the Unemployed laborers (% of total labor force) of Middle East & North Africa (developing only) in 2008 to that in 2009?
Give a very brief answer. 1.01. What is the ratio of the Unemployed laborers (% of total labor force) of Argentina in 2008 to that in 2009?
Keep it short and to the point. 0.91. What is the ratio of the Unemployed laborers (% of total labor force) of Europe(developing only) in 2008 to that in 2010?
Your answer should be very brief. 0.91. What is the ratio of the Unemployed laborers (% of total labor force) in Middle East & North Africa (developing only) in 2008 to that in 2010?
Your answer should be compact. 0.97. What is the ratio of the Unemployed laborers (% of total labor force) in Europe(developing only) in 2008 to that in 2011?
Keep it short and to the point. 0.96. What is the ratio of the Unemployed laborers (% of total labor force) in Middle East & North Africa (developing only) in 2008 to that in 2011?
Offer a very short reply. 0.95. What is the ratio of the Unemployed laborers (% of total labor force) of Middle East & North Africa (developing only) in 2008 to that in 2013?
Keep it short and to the point. 0.95. What is the ratio of the Unemployed laborers (% of total labor force) in Argentina in 2008 to that in 2013?
Offer a very short reply. 1.18. What is the ratio of the Unemployed laborers (% of total labor force) of Europe(developing only) in 2009 to that in 2010?
Give a very brief answer. 1.08. What is the ratio of the Unemployed laborers (% of total labor force) of Middle East & North Africa (developing only) in 2009 to that in 2010?
Your response must be concise. 0.95. What is the ratio of the Unemployed laborers (% of total labor force) in Argentina in 2009 to that in 2010?
Offer a very short reply. 1.12. What is the ratio of the Unemployed laborers (% of total labor force) in Europe(developing only) in 2009 to that in 2011?
Give a very brief answer. 1.14. What is the ratio of the Unemployed laborers (% of total labor force) in Middle East & North Africa (developing only) in 2009 to that in 2011?
Your answer should be compact. 0.94. What is the ratio of the Unemployed laborers (% of total labor force) in Argentina in 2009 to that in 2011?
Your answer should be compact. 1.19. What is the ratio of the Unemployed laborers (% of total labor force) of Europe(developing only) in 2009 to that in 2013?
Provide a succinct answer. 1.18. What is the ratio of the Unemployed laborers (% of total labor force) in Middle East & North Africa (developing only) in 2009 to that in 2013?
Offer a very short reply. 0.93. What is the ratio of the Unemployed laborers (% of total labor force) in Argentina in 2009 to that in 2013?
Offer a terse response. 1.3. What is the ratio of the Unemployed laborers (% of total labor force) of Europe(developing only) in 2010 to that in 2011?
Ensure brevity in your answer.  1.06. What is the ratio of the Unemployed laborers (% of total labor force) of Middle East & North Africa (developing only) in 2010 to that in 2011?
Offer a very short reply. 0.99. What is the ratio of the Unemployed laborers (% of total labor force) in Argentina in 2010 to that in 2011?
Ensure brevity in your answer.  1.07. What is the ratio of the Unemployed laborers (% of total labor force) of Europe(developing only) in 2010 to that in 2013?
Your response must be concise. 1.1. What is the ratio of the Unemployed laborers (% of total labor force) of Middle East & North Africa (developing only) in 2010 to that in 2013?
Make the answer very short. 0.98. What is the ratio of the Unemployed laborers (% of total labor force) of Argentina in 2010 to that in 2013?
Keep it short and to the point. 1.17. What is the ratio of the Unemployed laborers (% of total labor force) in Europe(developing only) in 2011 to that in 2013?
Your answer should be very brief. 1.04. What is the ratio of the Unemployed laborers (% of total labor force) of Middle East & North Africa (developing only) in 2011 to that in 2013?
Provide a succinct answer. 0.99. What is the difference between the highest and the second highest Unemployed laborers (% of total labor force) of Europe(developing only)?
Ensure brevity in your answer.  0.74. What is the difference between the highest and the second highest Unemployed laborers (% of total labor force) in Argentina?
Offer a very short reply. 0.5. What is the difference between the highest and the lowest Unemployed laborers (% of total labor force) in Europe(developing only)?
Give a very brief answer. 1.64. What is the difference between the highest and the lowest Unemployed laborers (% of total labor force) of Middle East & North Africa (developing only)?
Ensure brevity in your answer.  2.11. What is the difference between the highest and the lowest Unemployed laborers (% of total labor force) in Argentina?
Ensure brevity in your answer.  4. 